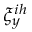<formula> <loc_0><loc_0><loc_500><loc_500>\xi _ { y } ^ { i h }</formula> 